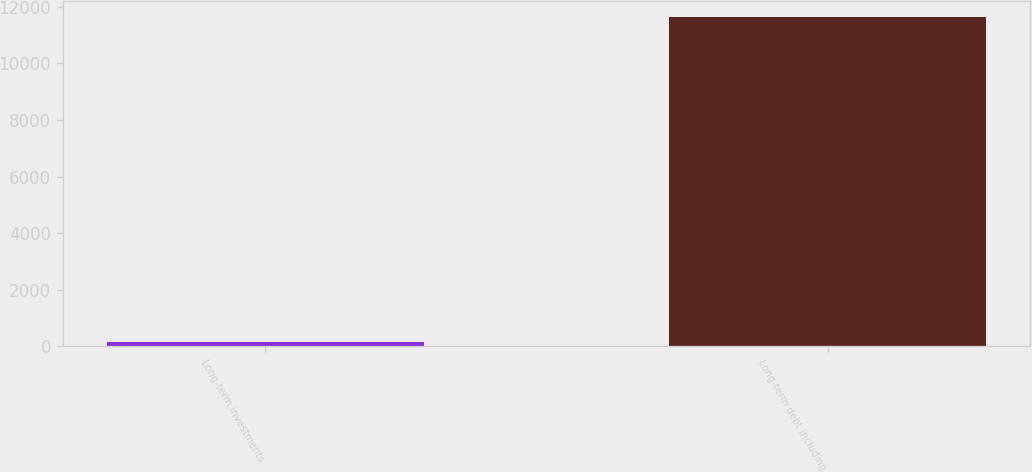Convert chart to OTSL. <chart><loc_0><loc_0><loc_500><loc_500><bar_chart><fcel>Long-term investments<fcel>Long-term debt including<nl><fcel>141<fcel>11626<nl></chart> 